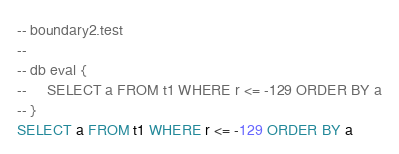<code> <loc_0><loc_0><loc_500><loc_500><_SQL_>-- boundary2.test
-- 
-- db eval {
--     SELECT a FROM t1 WHERE r <= -129 ORDER BY a
-- }
SELECT a FROM t1 WHERE r <= -129 ORDER BY a</code> 